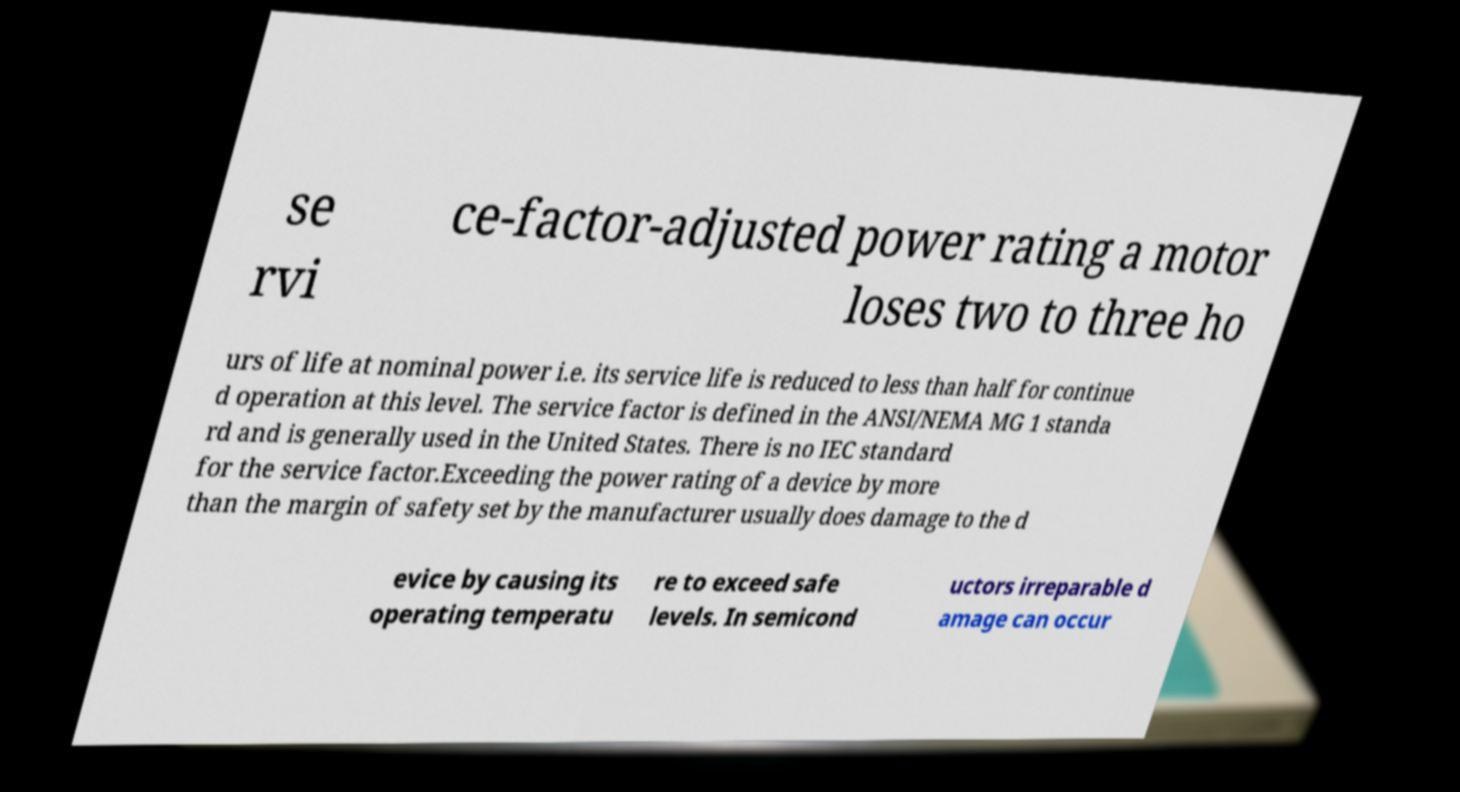Can you accurately transcribe the text from the provided image for me? se rvi ce-factor-adjusted power rating a motor loses two to three ho urs of life at nominal power i.e. its service life is reduced to less than half for continue d operation at this level. The service factor is defined in the ANSI/NEMA MG 1 standa rd and is generally used in the United States. There is no IEC standard for the service factor.Exceeding the power rating of a device by more than the margin of safety set by the manufacturer usually does damage to the d evice by causing its operating temperatu re to exceed safe levels. In semicond uctors irreparable d amage can occur 